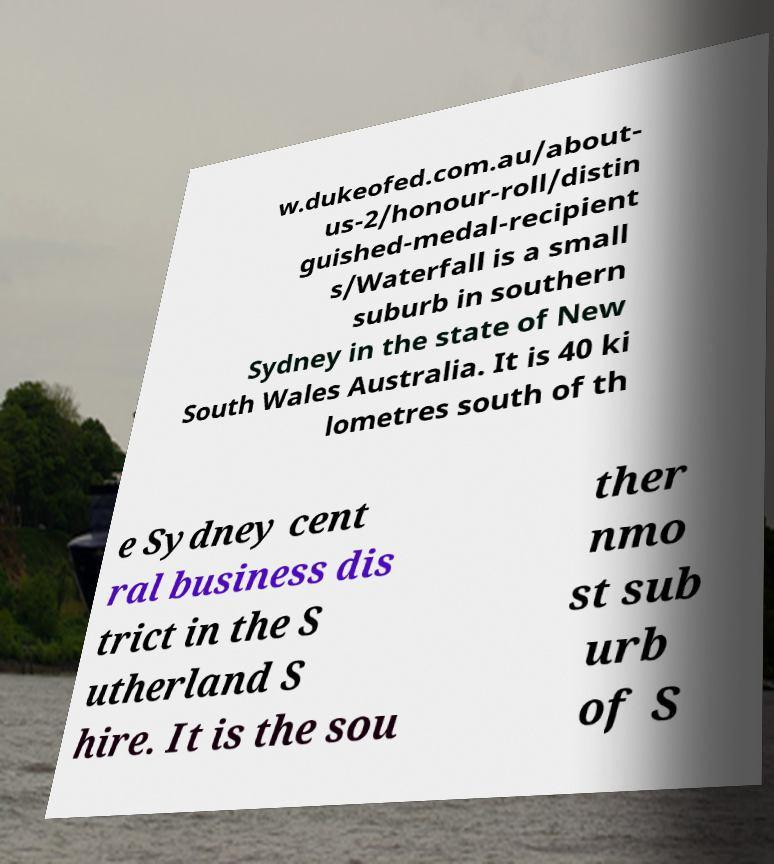Please read and relay the text visible in this image. What does it say? w.dukeofed.com.au/about- us-2/honour-roll/distin guished-medal-recipient s/Waterfall is a small suburb in southern Sydney in the state of New South Wales Australia. It is 40 ki lometres south of th e Sydney cent ral business dis trict in the S utherland S hire. It is the sou ther nmo st sub urb of S 